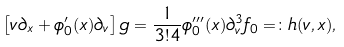Convert formula to latex. <formula><loc_0><loc_0><loc_500><loc_500>\left [ v \partial _ { x } + \phi _ { 0 } ^ { \prime } ( x ) \partial _ { v } \right ] g = \frac { 1 } { 3 ! 4 } \phi _ { 0 } ^ { \prime \prime \prime } ( x ) \partial _ { v } ^ { 3 } f _ { 0 } = \colon h ( v , x ) ,</formula> 